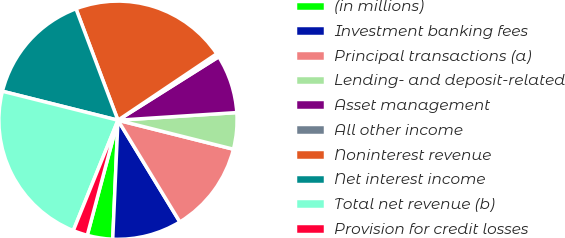Convert chart to OTSL. <chart><loc_0><loc_0><loc_500><loc_500><pie_chart><fcel>(in millions)<fcel>Investment banking fees<fcel>Principal transactions (a)<fcel>Lending- and deposit-related<fcel>Asset management<fcel>All other income<fcel>Noninterest revenue<fcel>Net interest income<fcel>Total net revenue (b)<fcel>Provision for credit losses<nl><fcel>3.45%<fcel>9.4%<fcel>12.38%<fcel>4.94%<fcel>7.92%<fcel>0.48%<fcel>21.31%<fcel>15.36%<fcel>22.79%<fcel>1.97%<nl></chart> 